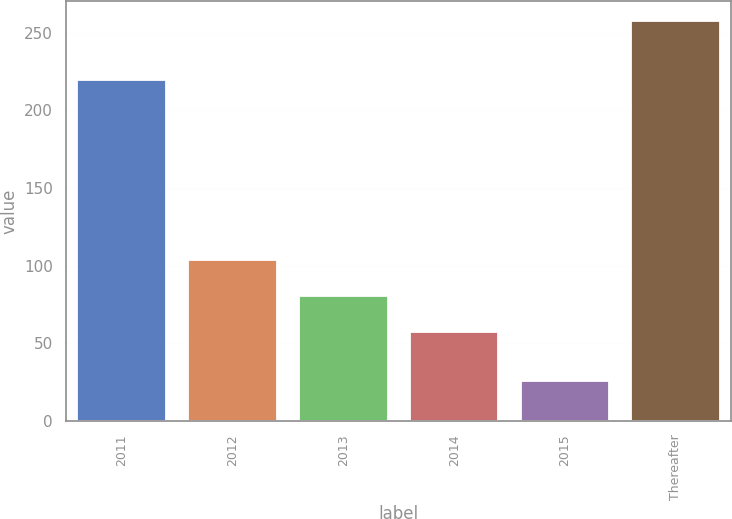Convert chart. <chart><loc_0><loc_0><loc_500><loc_500><bar_chart><fcel>2011<fcel>2012<fcel>2013<fcel>2014<fcel>2015<fcel>Thereafter<nl><fcel>219.8<fcel>103.42<fcel>80.21<fcel>57<fcel>25.6<fcel>257.7<nl></chart> 